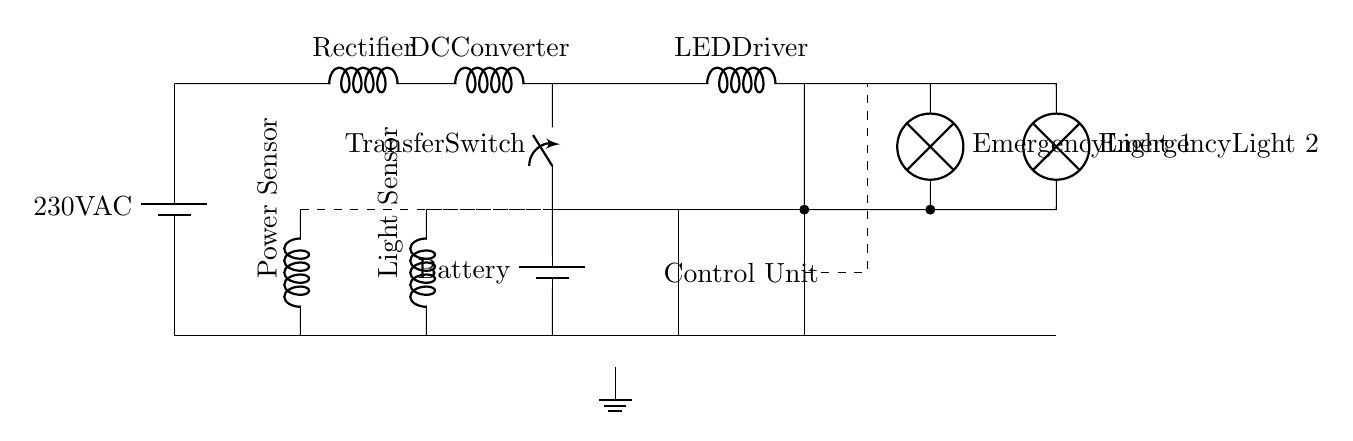What type of power supply is shown in the circuit? The circuit diagram displays a battery with a label indicating it provides alternating current at 230 volts. This is common for power supplies in residential and commercial settings.
Answer: 230V AC What are the two types of sensors included in the circuit? The circuit has two sensors: one labeled as a power sensor located to the left and another labeled as a light sensor slightly further right. Both sensors play crucial roles in monitoring conditions.
Answer: Power Sensor and Light Sensor What component allows automatic switching between power sources? The component that facilitates automatic switching is labeled as the Transfer Switch. It connects the main power supply to the LED driver, ensuring operation under varying conditions.
Answer: Transfer Switch How many emergency lights are depicted in this circuit? The circuit shows two emergency lights, each labeled as Emergency Light 1 and Emergency Light 2. This redundancy is important for safety in care home environments.
Answer: Two What is the function of the control unit in this circuit? The Control Unit is denoted within a rectangle and is responsible for managing the operation of the emergency lighting system. It processes input from the sensors to activate lights as needed.
Answer: To manage emergency lighting What is the role of the LED driver in this circuit? The LED Driver converts the received power to a suitable format for the emergency lights, ensuring they operate correctly and efficiently when activated by the control unit.
Answer: Converts power for lights What does the dashed line indicate in this circuit diagram? The dashed lines in the circuit represent connections between the various components, particularly connecting the sensors to the control unit for data communication and functionality.
Answer: Connections 